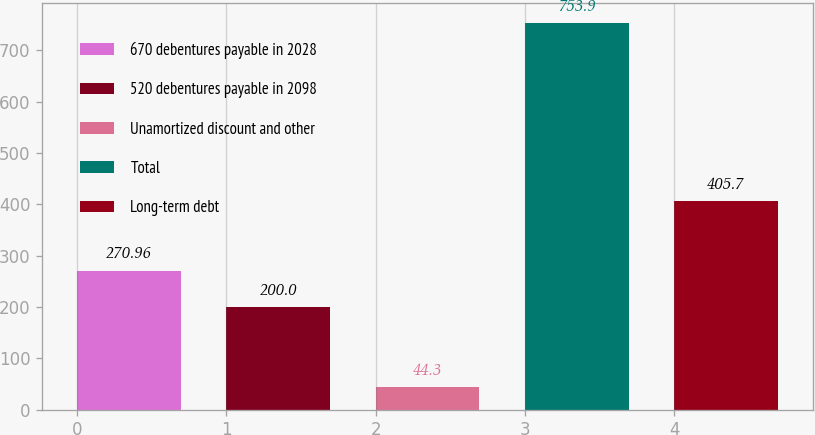Convert chart. <chart><loc_0><loc_0><loc_500><loc_500><bar_chart><fcel>670 debentures payable in 2028<fcel>520 debentures payable in 2098<fcel>Unamortized discount and other<fcel>Total<fcel>Long-term debt<nl><fcel>270.96<fcel>200<fcel>44.3<fcel>753.9<fcel>405.7<nl></chart> 